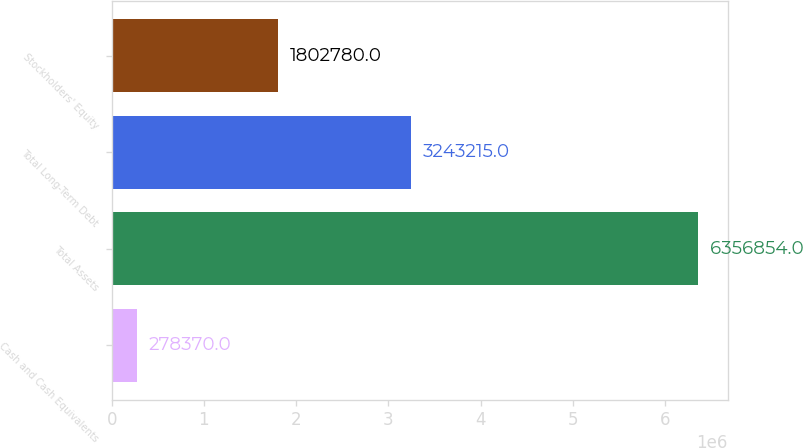<chart> <loc_0><loc_0><loc_500><loc_500><bar_chart><fcel>Cash and Cash Equivalents<fcel>Total Assets<fcel>Total Long-Term Debt<fcel>Stockholders' Equity<nl><fcel>278370<fcel>6.35685e+06<fcel>3.24322e+06<fcel>1.80278e+06<nl></chart> 